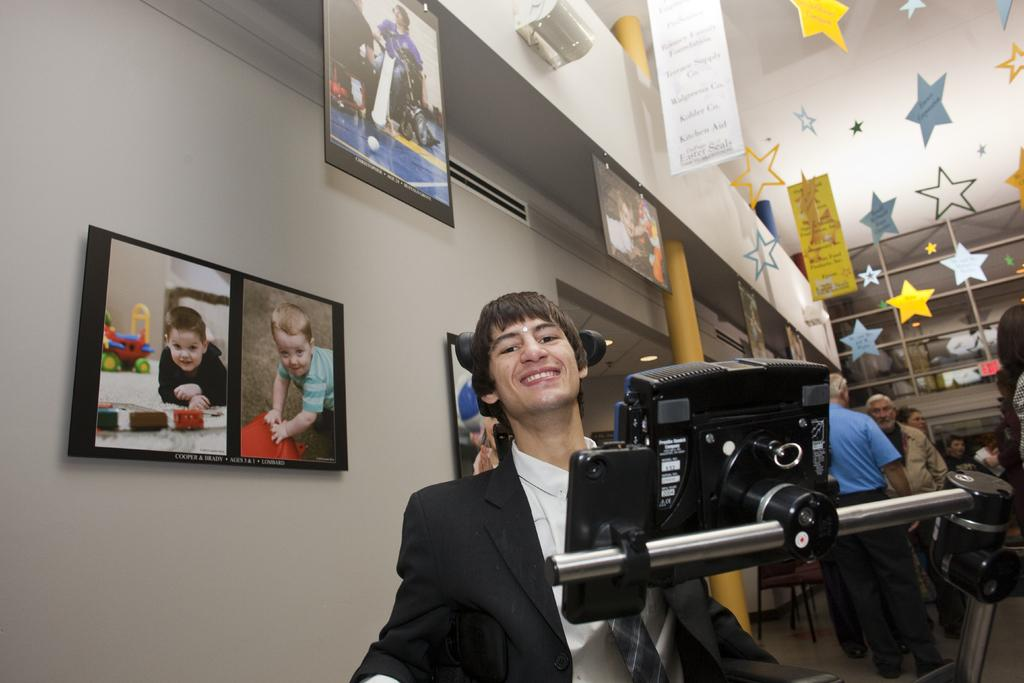What can be seen on the wall in the image? There are pictures on the wall. What objects are on a stand in the image? A mobile and a camera are on a stand. What is the man in the image wearing? The man is wearing a suit. What can be seen in the background of the image? There are people, stars, and banners in the background. How many dimes can be seen on the man's suit in the image? There are no dimes visible on the man's suit in the image. Is there a boy in the image? There is no mention of a boy in the provided facts, so we cannot definitively say if there is one in the image. --- Facts: 1. There is a car in the image. 2. The car is red. 3. The car has four wheels. 4. There are people in the car. 5. The car is parked on the street. 6. There are trees on the street. Absurd Topics: bird, ocean, mountain Conversation: What is the color of the car in the image? The car is red. How many wheels does the car have? The car has four wheels. Who is inside the car? There are people in the car. Where is the car located in the image? The car is parked on the street. What can be seen on the street in the image? There are trees on the street. Reasoning: Let's think step by step in order to produce the conversation. We start by identifying the main subject in the image, which is the car. Then, we expand the conversation to include other details about the car, such as its color and the number of wheels. We also mention the people inside the car and the location of the car on the street. Finally, we include information about the trees on the street. Absurd Question/Answer: Can you see any birds flying over the ocean in the image? There is no mention of birds, an ocean, or a mountain in the provided facts, so we cannot definitively say if they are present in the image. 